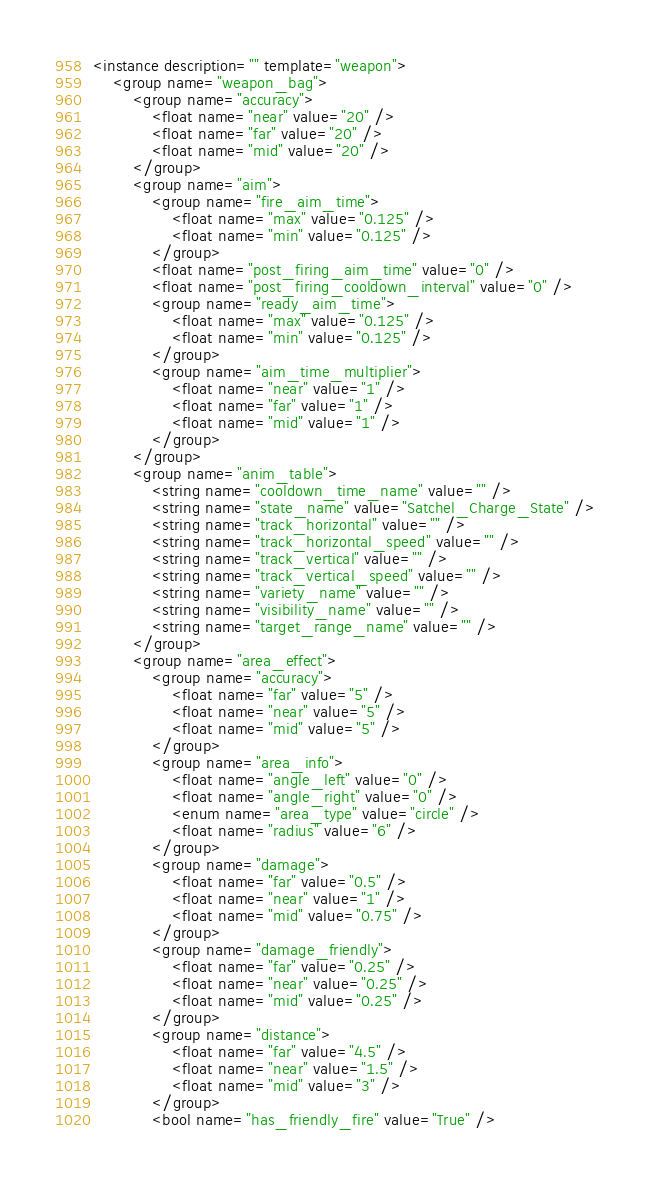Convert code to text. <code><loc_0><loc_0><loc_500><loc_500><_XML_><instance description="" template="weapon">
	<group name="weapon_bag">
		<group name="accuracy">
			<float name="near" value="20" />
			<float name="far" value="20" />
			<float name="mid" value="20" />
		</group>
		<group name="aim">
			<group name="fire_aim_time">
				<float name="max" value="0.125" />
				<float name="min" value="0.125" />
			</group>
			<float name="post_firing_aim_time" value="0" />
			<float name="post_firing_cooldown_interval" value="0" />
			<group name="ready_aim_time">
				<float name="max" value="0.125" />
				<float name="min" value="0.125" />
			</group>
			<group name="aim_time_multiplier">
				<float name="near" value="1" />
				<float name="far" value="1" />
				<float name="mid" value="1" />
			</group>
		</group>
		<group name="anim_table">
			<string name="cooldown_time_name" value="" />
			<string name="state_name" value="Satchel_Charge_State" />
			<string name="track_horizontal" value="" />
			<string name="track_horizontal_speed" value="" />
			<string name="track_vertical" value="" />
			<string name="track_vertical_speed" value="" />
			<string name="variety_name" value="" />
			<string name="visibility_name" value="" />
			<string name="target_range_name" value="" />
		</group>
		<group name="area_effect">
			<group name="accuracy">
				<float name="far" value="5" />
				<float name="near" value="5" />
				<float name="mid" value="5" />
			</group>
			<group name="area_info">
				<float name="angle_left" value="0" />
				<float name="angle_right" value="0" />
				<enum name="area_type" value="circle" />
				<float name="radius" value="6" />
			</group>
			<group name="damage">
				<float name="far" value="0.5" />
				<float name="near" value="1" />
				<float name="mid" value="0.75" />
			</group>
			<group name="damage_friendly">
				<float name="far" value="0.25" />
				<float name="near" value="0.25" />
				<float name="mid" value="0.25" />
			</group>
			<group name="distance">
				<float name="far" value="4.5" />
				<float name="near" value="1.5" />
				<float name="mid" value="3" />
			</group>
			<bool name="has_friendly_fire" value="True" /></code> 